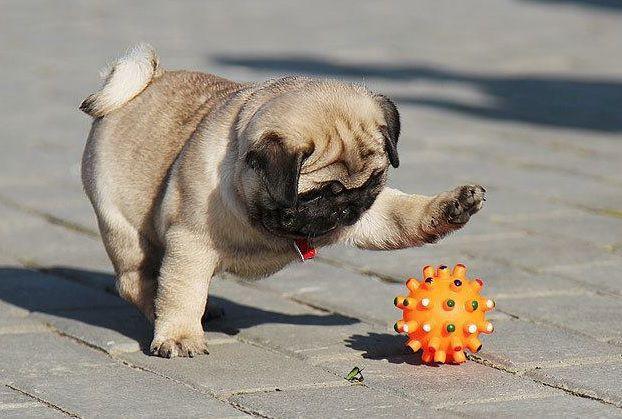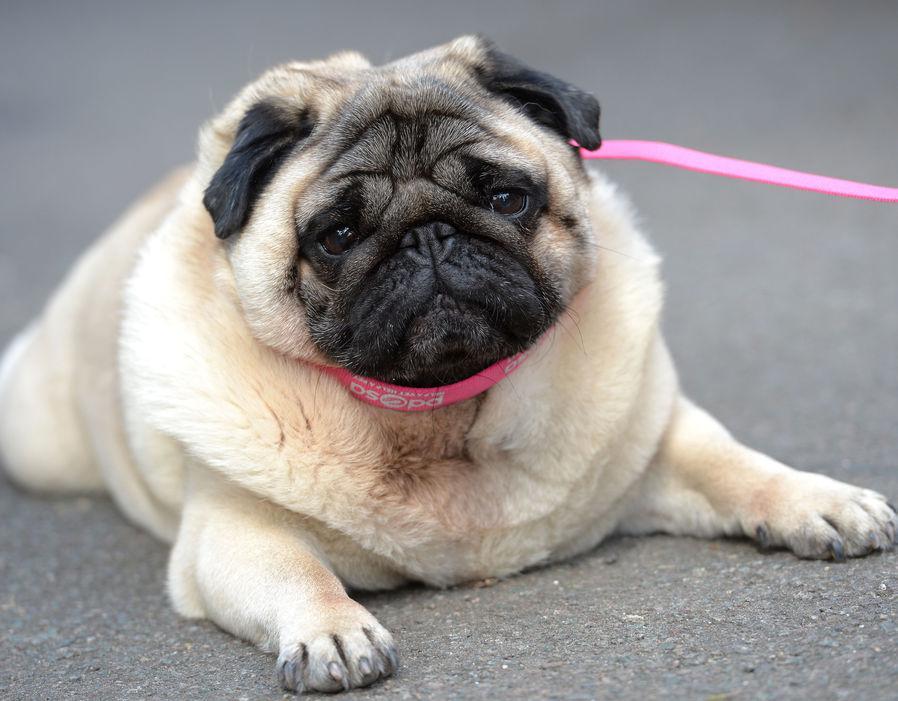The first image is the image on the left, the second image is the image on the right. For the images shown, is this caption "The dog on the right is posing with a black and white ball" true? Answer yes or no. No. The first image is the image on the left, the second image is the image on the right. Analyze the images presented: Is the assertion "In one image a dog is with a soccer ball toy." valid? Answer yes or no. No. 